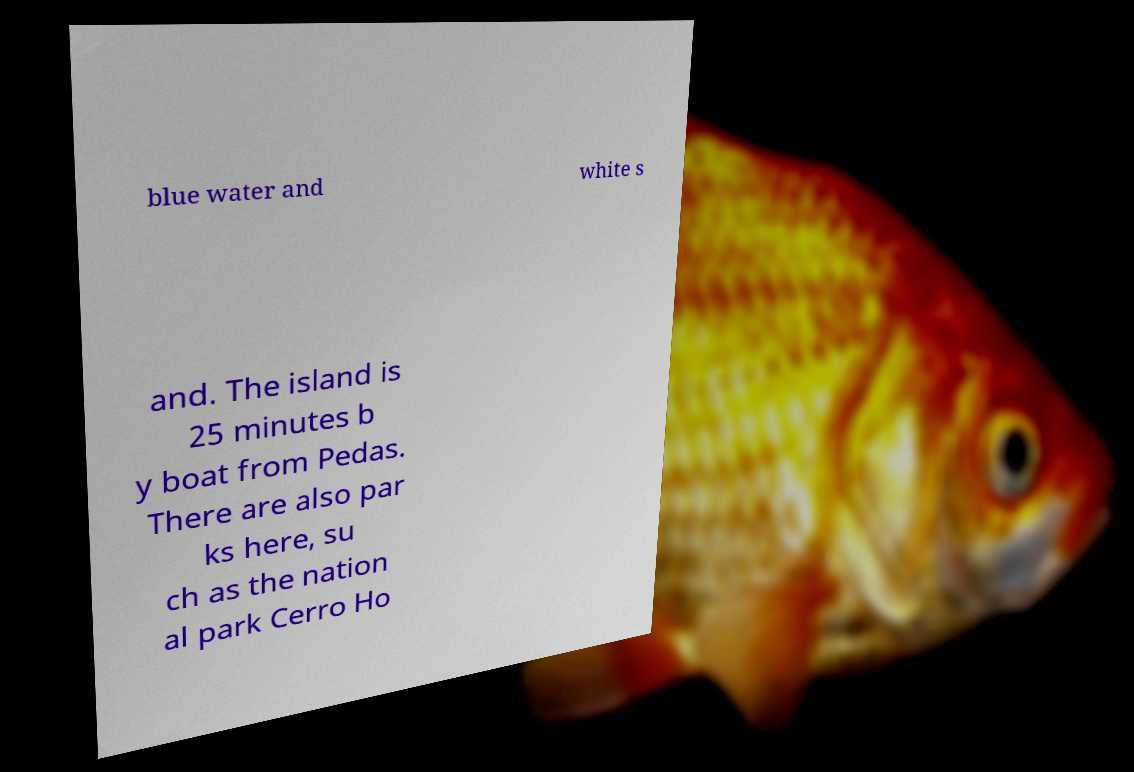Please read and relay the text visible in this image. What does it say? blue water and white s and. The island is 25 minutes b y boat from Pedas. There are also par ks here, su ch as the nation al park Cerro Ho 